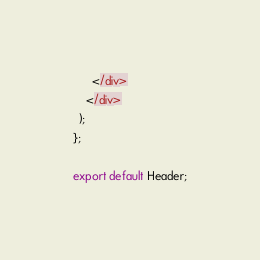<code> <loc_0><loc_0><loc_500><loc_500><_JavaScript_>      </div>
    </div>
  );
};

export default Header;</code> 